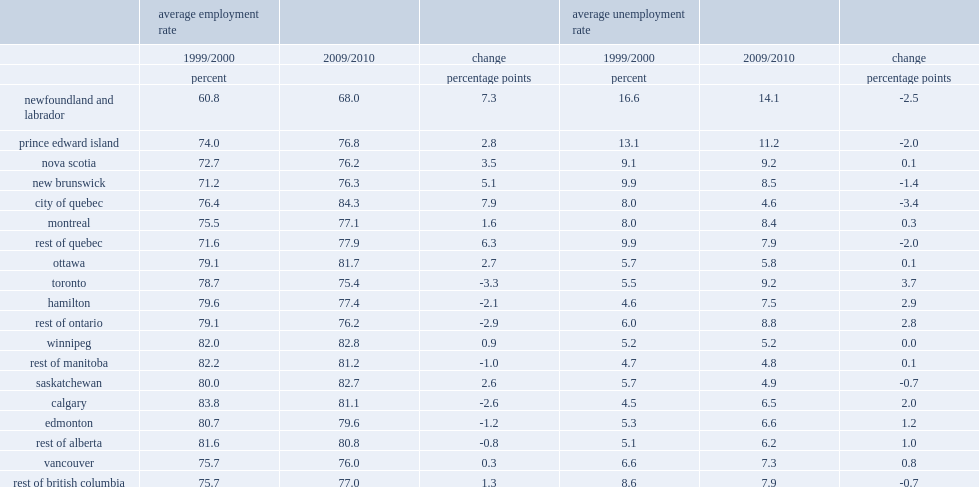Which three places rose most in the unemployment rate between 1999/2000 and 2009/2010? Toronto hamilton rest of ontario. Which place in provinces west of ontario has the lower rose in unemployment rates? Ottawa. 